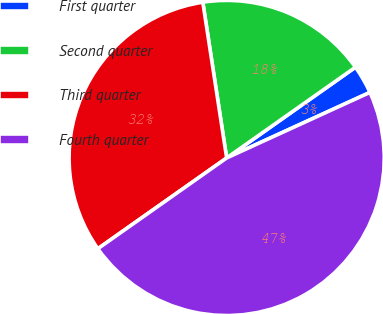Convert chart. <chart><loc_0><loc_0><loc_500><loc_500><pie_chart><fcel>First quarter<fcel>Second quarter<fcel>Third quarter<fcel>Fourth quarter<nl><fcel>2.94%<fcel>17.65%<fcel>32.35%<fcel>47.06%<nl></chart> 